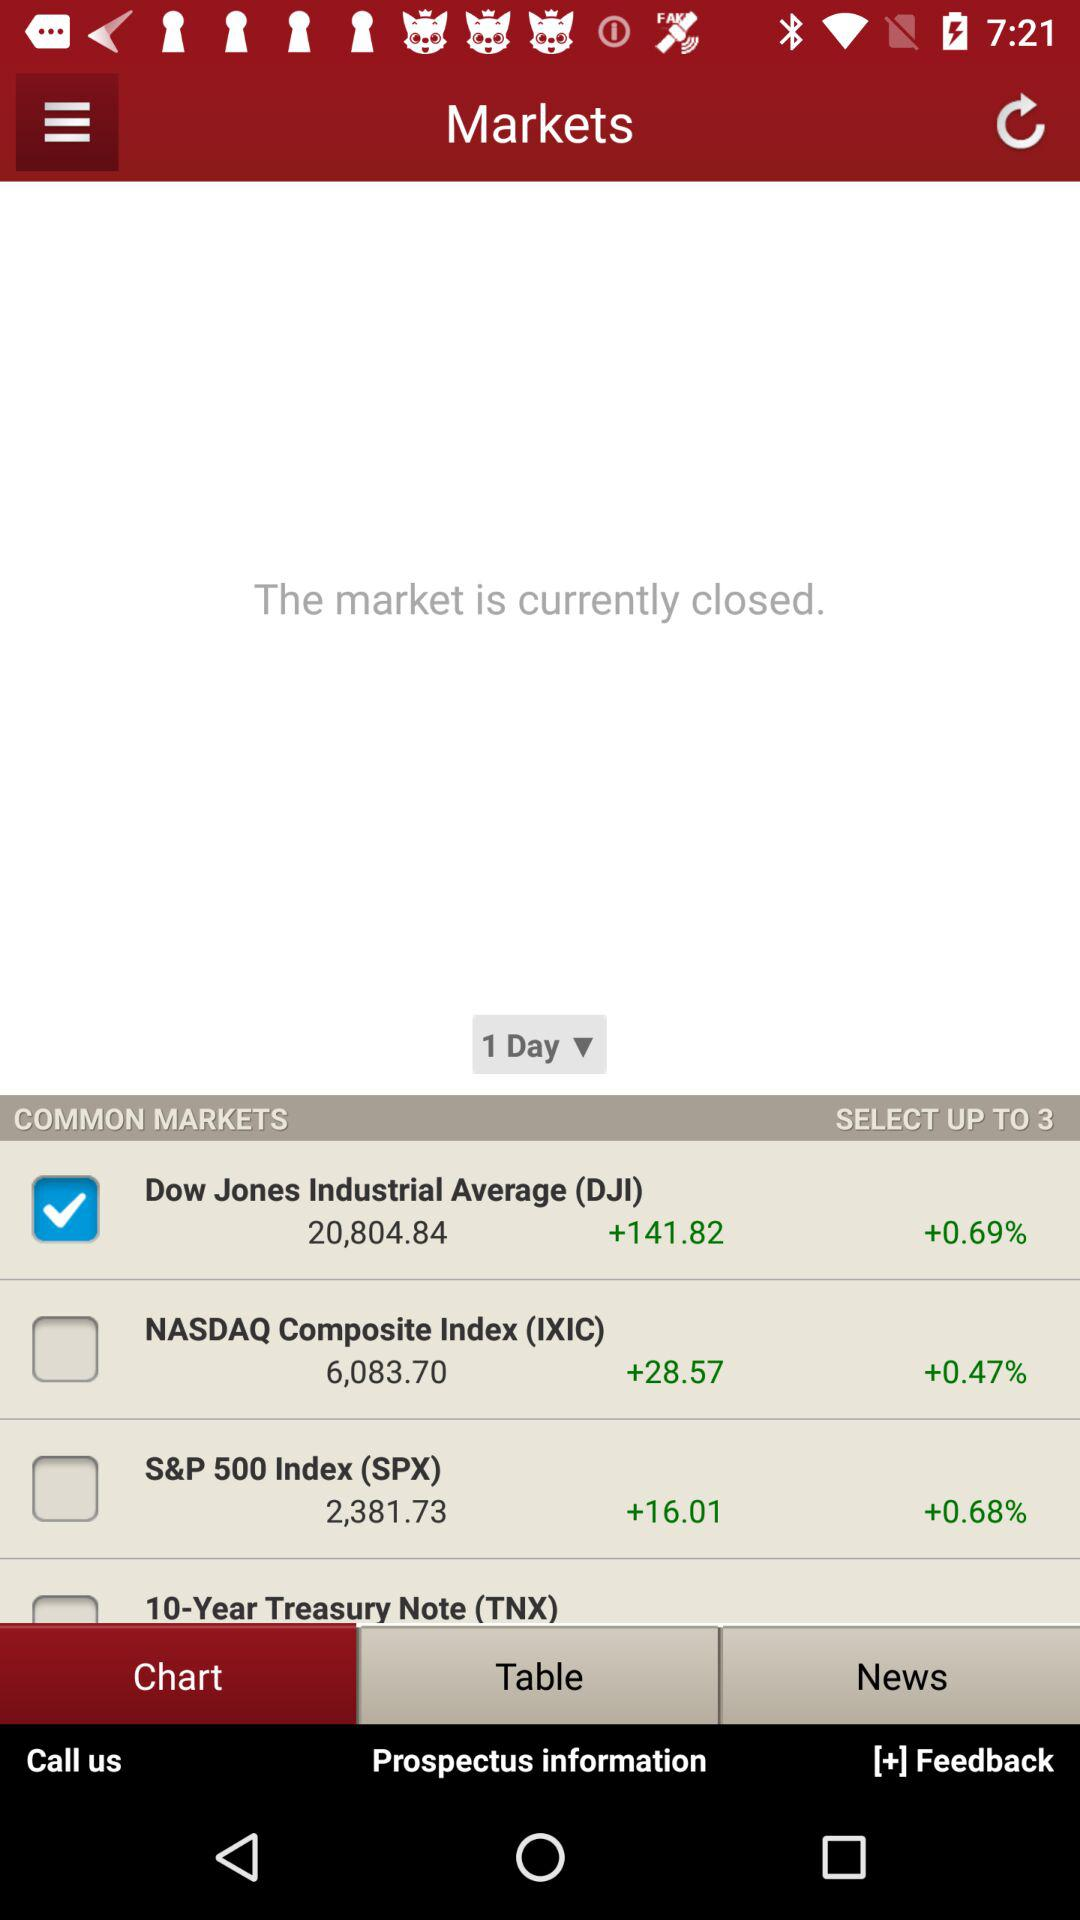How many stocks can one select up to? One can select up to 3 stocks. 